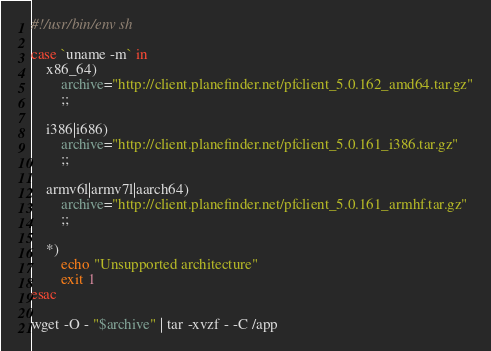Convert code to text. <code><loc_0><loc_0><loc_500><loc_500><_Bash_>#!/usr/bin/env sh

case `uname -m` in
    x86_64)
        archive="http://client.planefinder.net/pfclient_5.0.162_amd64.tar.gz"
        ;;

    i386|i686)
        archive="http://client.planefinder.net/pfclient_5.0.161_i386.tar.gz"
        ;;

    armv6l|armv7l|aarch64)
        archive="http://client.planefinder.net/pfclient_5.0.161_armhf.tar.gz"
        ;;

    *)
        echo "Unsupported architecture"
        exit 1
esac

wget -O - "$archive" | tar -xvzf - -C /app
</code> 